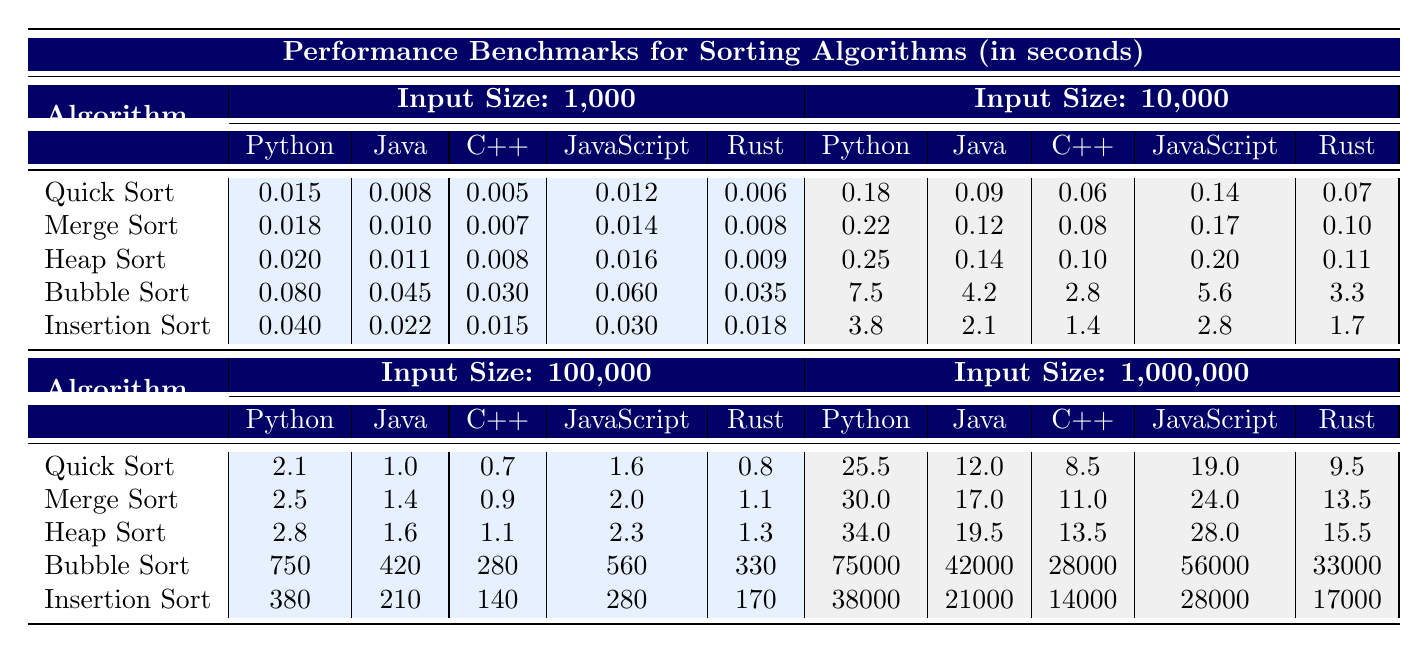What is the fastest sorting algorithm in Python for an input size of 1,000? By looking at the table, the execution time for each sorting algorithm in Python for an input size of 1,000 is listed. The fastest time is 0.005 seconds for Quick Sort.
Answer: Quick Sort What is the execution time of Bubble Sort in C++ for an input size of 100,000? The table shows that the execution time of Bubble Sort in C++ for an input size of 100,000 is 280 seconds.
Answer: 280 Which programming language has the fastest Merge Sort execution at an input size of 10,000? The table indicates that for Merge Sort at an input size of 10,000, C++ has the fastest execution time of 0.08 seconds compared to others.
Answer: C++ What is the average execution time for Heap Sort across all programming languages at an input size of 1,000,000? To find the average, we sum the execution times of Heap Sort in each language at this input size: (34.0 + 19.5 + 13.5 + 28.0 + 15.5) = 110.5 seconds, then divide by the number of languages (5), which gives us 110.5 / 5 = 22.1 seconds.
Answer: 22.1 Is Rust faster than Java for Quick Sort at an input size of 100,000? The table shows that the execution time for Quick Sort in Rust is 0.8 seconds, while in Java it is 1.0 seconds. Since 0.8 is less than 1.0, Rust is indeed faster than Java for this scenario.
Answer: Yes Which algorithm takes the most time in Python for an input size of 1,000,000? The table lists the execution times for each algorithm in Python. For an input size of 1,000,000, Bubble Sort has the highest execution time of 75000 seconds compared to others.
Answer: Bubble Sort What is the total execution time for Insertion Sort in Java across the four different input sizes? By adding up the execution times of Insertion Sort in Java for each input size: (0.022 + 2.1 + 210 + 21000) = 21212.122 seconds.
Answer: 21212.122 Which sorting algorithm has the least time increase from input size 100,000 to 1,000,000 in Python? Comparing the increases in execution time from 100,000 to 1,000,000 for each algorithm in Python: Quick Sort increases from 2.1 to 25.5 (23.4 increase), Merge Sort from 2.5 to 30.0 (27.5 increase), Heap Sort from 2.8 to 34.0 (31.2 increase), Insertion Sort from 380 to 38000 (37620 increase), and Bubble Sort from 750 to 75000 (74250 increase). Quick Sort has the least increase at 23.4 seconds.
Answer: Quick Sort 